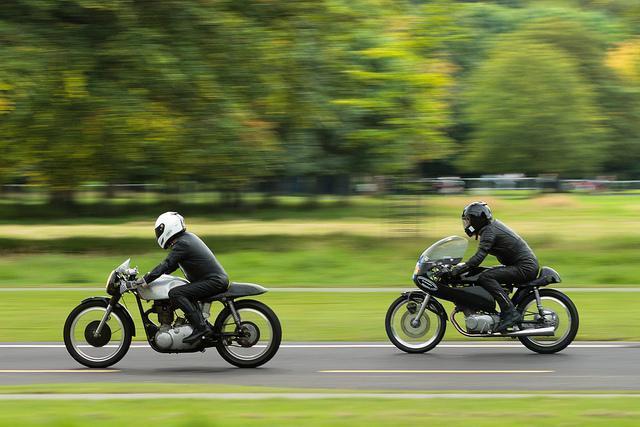How many motorcycles are there?
Give a very brief answer. 2. How many people can you see?
Give a very brief answer. 2. 